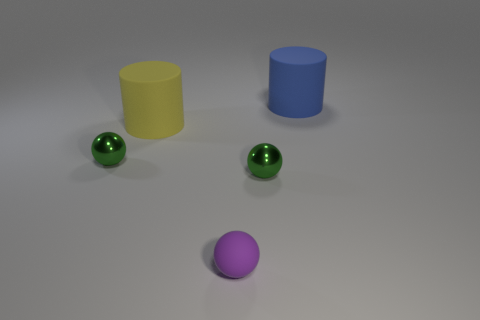Add 5 big purple cylinders. How many objects exist? 10 Subtract 0 cyan balls. How many objects are left? 5 Subtract all cylinders. How many objects are left? 3 Subtract all blue cylinders. Subtract all big yellow rubber cylinders. How many objects are left? 3 Add 2 small purple things. How many small purple things are left? 3 Add 1 red metal cylinders. How many red metal cylinders exist? 1 